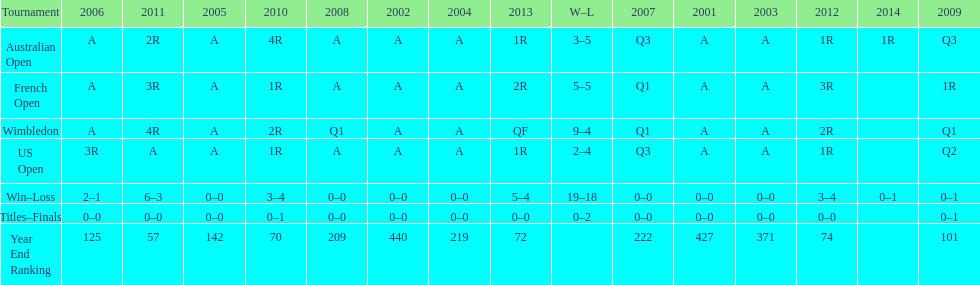In what year was the best year end ranking achieved? 2011. 